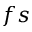Convert formula to latex. <formula><loc_0><loc_0><loc_500><loc_500>f s</formula> 